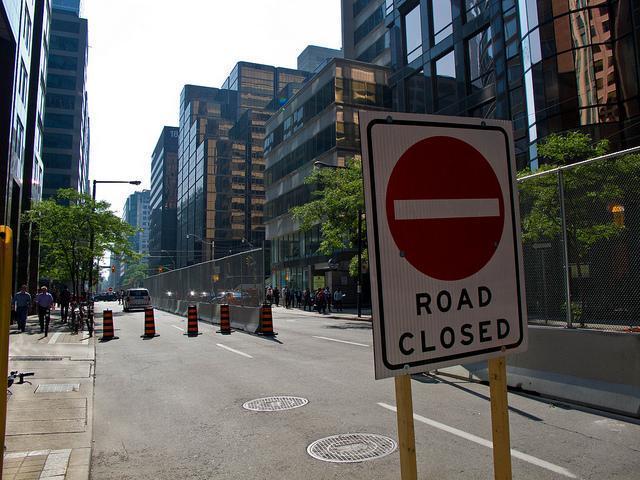How many manhole covers are shown?
Give a very brief answer. 2. How many birds stand on the sand?
Give a very brief answer. 0. 